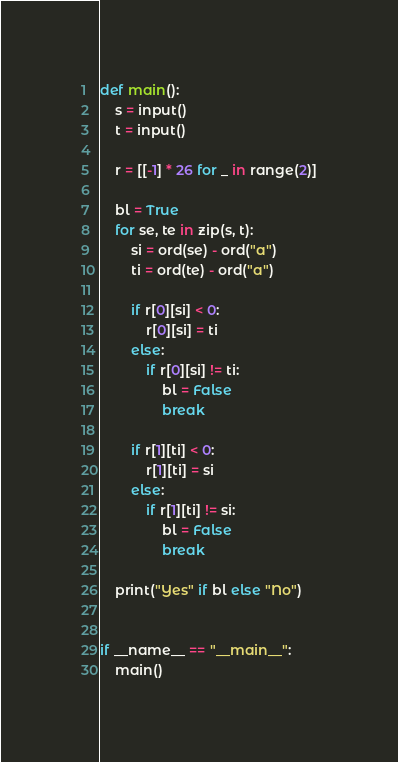<code> <loc_0><loc_0><loc_500><loc_500><_Python_>def main():
    s = input()
    t = input()

    r = [[-1] * 26 for _ in range(2)]

    bl = True
    for se, te in zip(s, t):
        si = ord(se) - ord("a")
        ti = ord(te) - ord("a")

        if r[0][si] < 0:
            r[0][si] = ti
        else:
            if r[0][si] != ti:
                bl = False
                break

        if r[1][ti] < 0:
            r[1][ti] = si
        else:
            if r[1][ti] != si:
                bl = False
                break

    print("Yes" if bl else "No")


if __name__ == "__main__":
    main()
</code> 